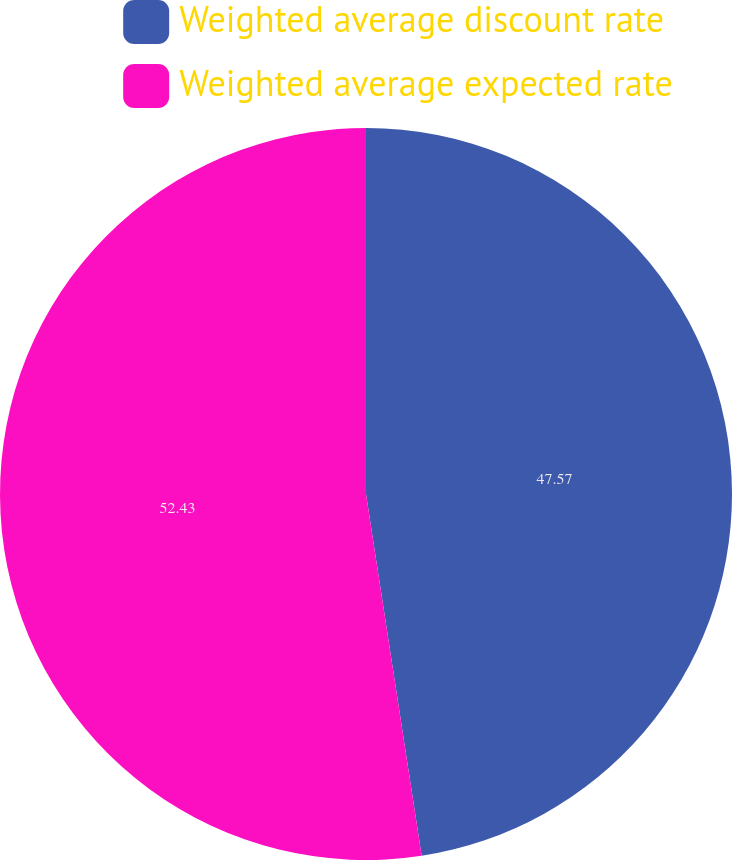Convert chart. <chart><loc_0><loc_0><loc_500><loc_500><pie_chart><fcel>Weighted average discount rate<fcel>Weighted average expected rate<nl><fcel>47.57%<fcel>52.43%<nl></chart> 